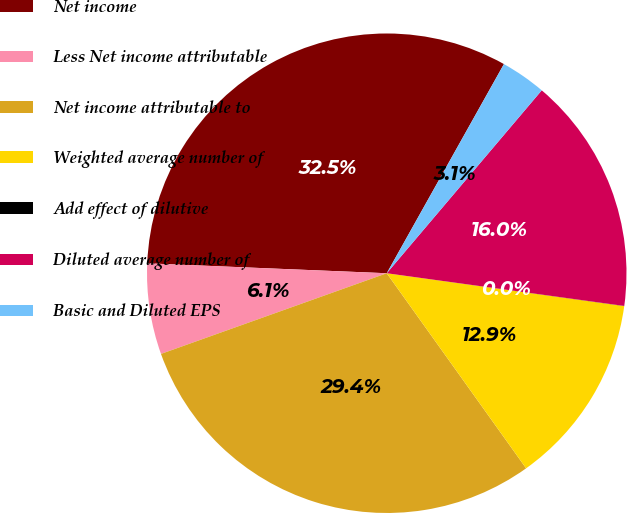Convert chart to OTSL. <chart><loc_0><loc_0><loc_500><loc_500><pie_chart><fcel>Net income<fcel>Less Net income attributable<fcel>Net income attributable to<fcel>Weighted average number of<fcel>Add effect of dilutive<fcel>Diluted average number of<fcel>Basic and Diluted EPS<nl><fcel>32.47%<fcel>6.12%<fcel>29.41%<fcel>12.94%<fcel>0.01%<fcel>15.99%<fcel>3.06%<nl></chart> 